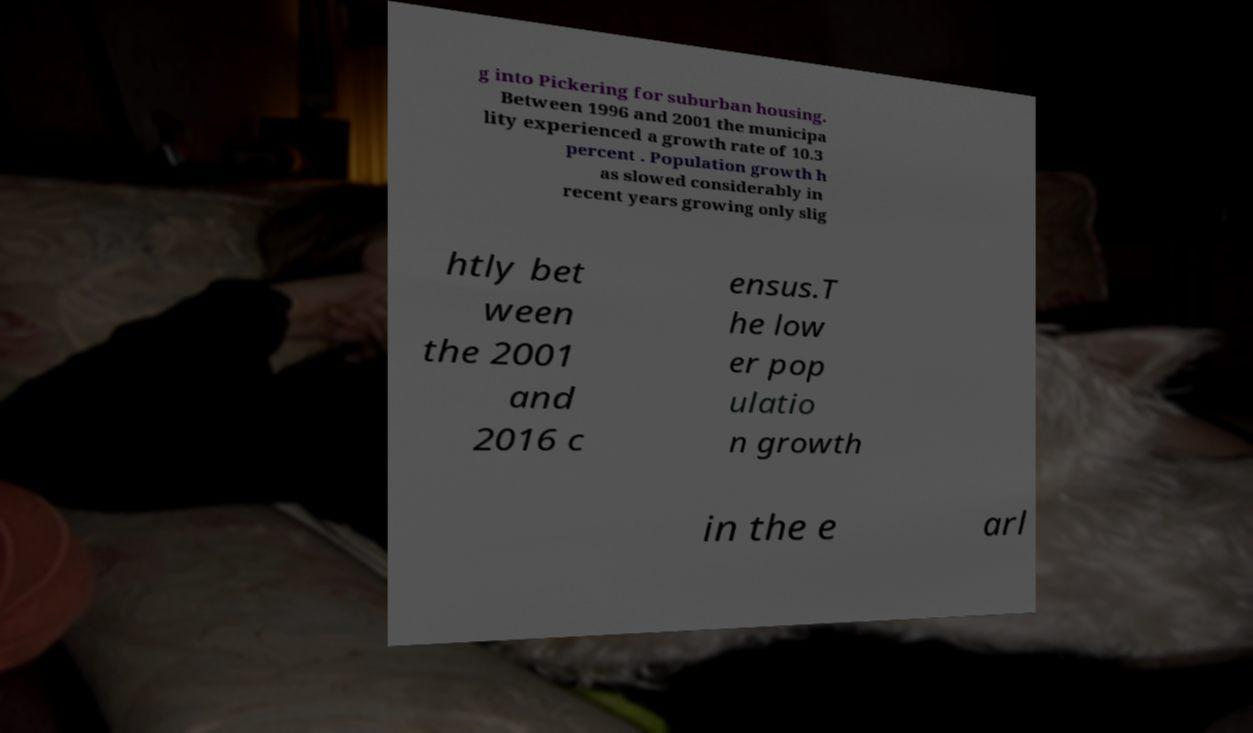Could you assist in decoding the text presented in this image and type it out clearly? g into Pickering for suburban housing. Between 1996 and 2001 the municipa lity experienced a growth rate of 10.3 percent . Population growth h as slowed considerably in recent years growing only slig htly bet ween the 2001 and 2016 c ensus.T he low er pop ulatio n growth in the e arl 